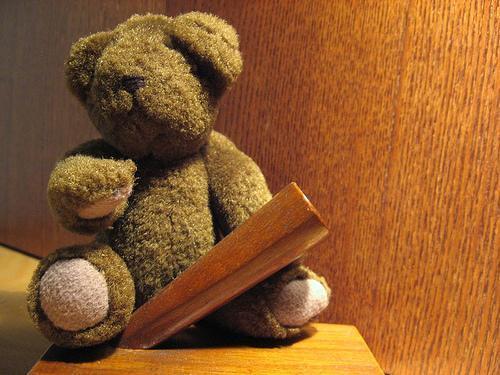How many teddy bears are in the image?
Give a very brief answer. 1. 